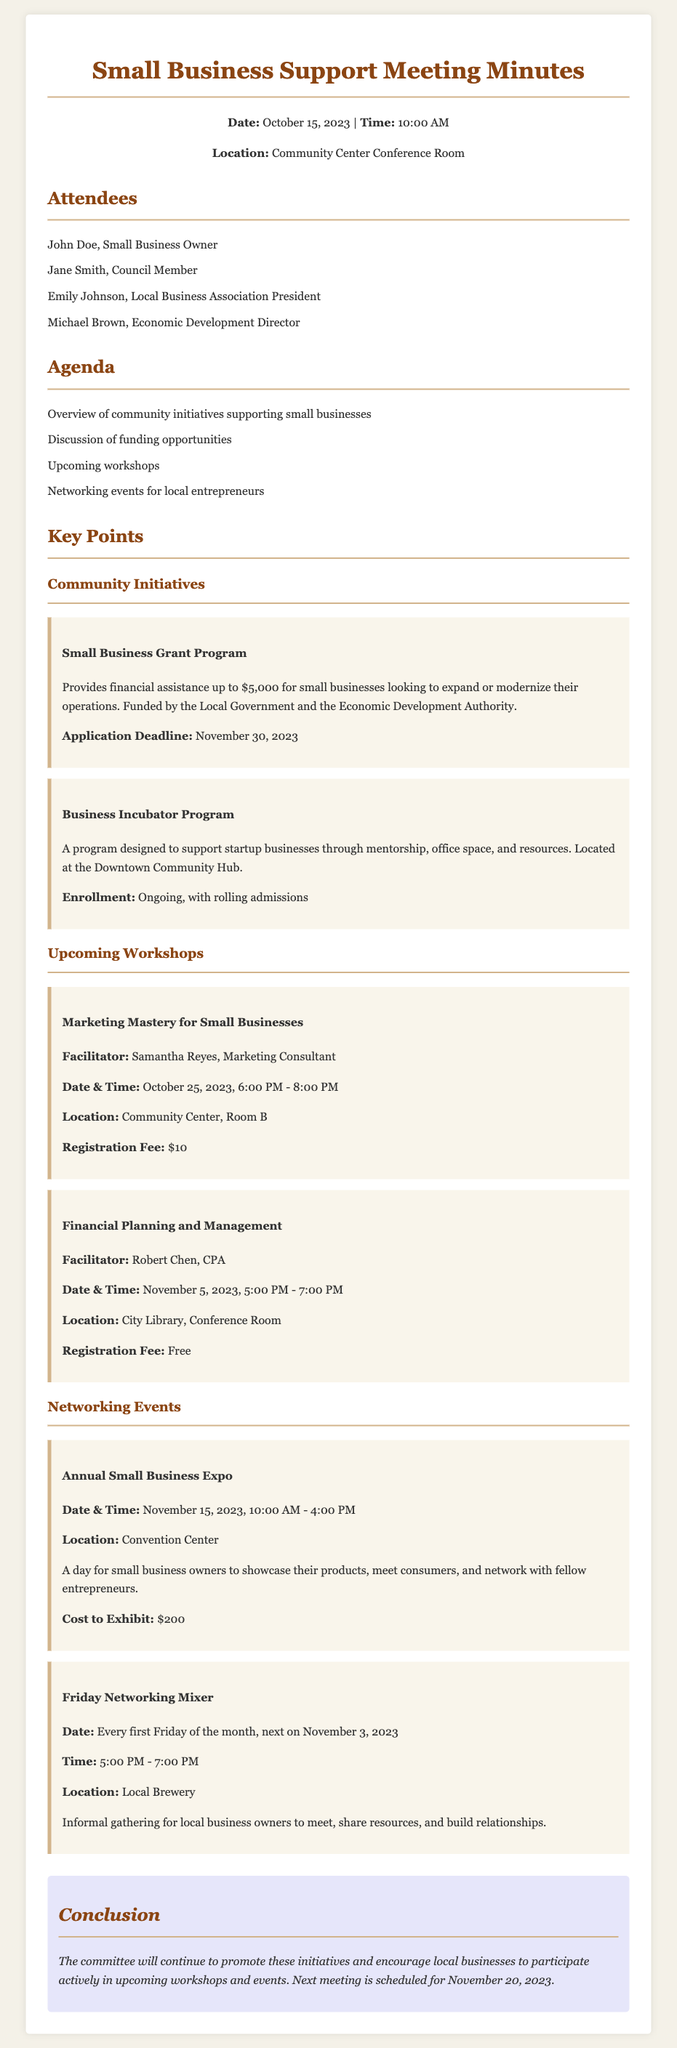What is the application deadline for the Small Business Grant Program? The document states that the application deadline for the Small Business Grant Program is November 30, 2023.
Answer: November 30, 2023 Who is the facilitator for the Marketing Mastery workshop? According to the document, the facilitator for the Marketing Mastery workshop is Samantha Reyes.
Answer: Samantha Reyes What is the registration fee for the Financial Planning and Management workshop? The document mentions that the registration fee for this workshop is free.
Answer: Free How much can a small business receive from the Small Business Grant Program? The document specifies that small businesses can receive up to $5,000 from the Small Business Grant Program.
Answer: $5,000 When is the next Friday Networking Mixer scheduled? The document indicates that the next Friday Networking Mixer is on November 3, 2023.
Answer: November 3, 2023 What type of program is the Business Incubator Program? The document describes the Business Incubator Program as designed to support startup businesses through mentorship, office space, and resources.
Answer: Support startup businesses through mentorship, office space, and resources What is the cost to exhibit at the Annual Small Business Expo? The document states that the cost to exhibit at the Annual Small Business Expo is $200.
Answer: $200 When is the next meeting scheduled? The document states that the next meeting is scheduled for November 20, 2023.
Answer: November 20, 2023 Where is the Marketing Mastery workshop located? According to the document, the Marketing Mastery workshop is located at the Community Center, Room B.
Answer: Community Center, Room B 